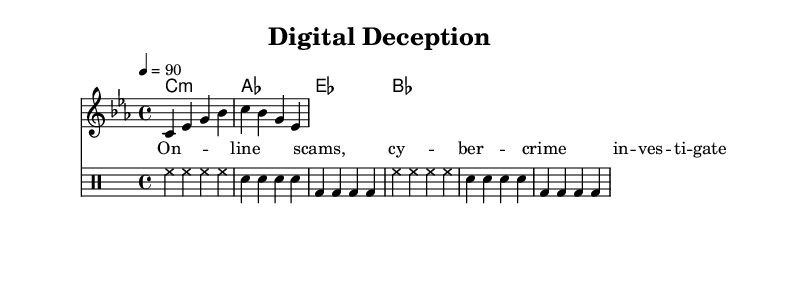What is the key signature of this music? The key signature is C minor, indicated by three flats in the key signature. It defines the tonal center of the music and determines the notes that will typically be sharped or flatted throughout the piece.
Answer: C minor What is the time signature of this music? The time signature is 4/4, which means there are four beats per measure and the quarter note receives one beat. The top number indicates how many beats are in each measure.
Answer: 4/4 What is the tempo marking of this music? The tempo marking is 90 beats per minute, suggesting that each quarter note is played at a moderate pace. This helps musicians understand how fast or slow to perform the piece.
Answer: 90 How many measures are in the melody? The melody contains four measures, as indicated by the musical notation that divides the staff into groups that represent measures. Each group is separated by vertical lines.
Answer: 4 What is the rhythmic pattern of the drum staff? The rhythmic pattern alternates between hi-hat, snare, and bass drum notes, creating a repetitive groove that is common in rap music. Each part maintains a consistent beat throughout the measures.
Answer: Repetitive groove What lyrical theme is introduced in the lyrics? The theme introduced is about investigating online scams and cybercrime, reflecting the gritty urban storytelling characteristic of rap. The lyrics set up the narrative focus of the song.
Answer: Online scams How does the harmony support the melody? The harmony consists of a series of chords that provide harmonic support underneath the melody, enhancing its emotional impact and creating a fuller sound. The chord changes typically align with significant beats in the melody.
Answer: Harmonic support 